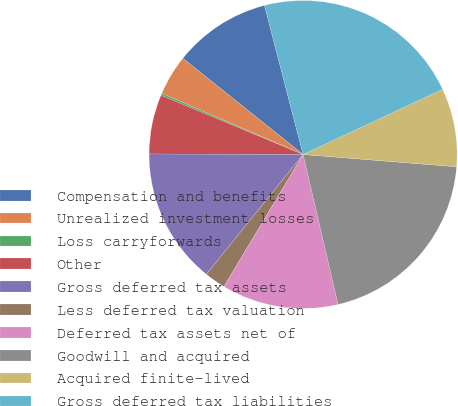Convert chart. <chart><loc_0><loc_0><loc_500><loc_500><pie_chart><fcel>Compensation and benefits<fcel>Unrealized investment losses<fcel>Loss carryforwards<fcel>Other<fcel>Gross deferred tax assets<fcel>Less deferred tax valuation<fcel>Deferred tax assets net of<fcel>Goodwill and acquired<fcel>Acquired finite-lived<fcel>Gross deferred tax liabilities<nl><fcel>10.23%<fcel>4.23%<fcel>0.22%<fcel>6.23%<fcel>14.24%<fcel>2.22%<fcel>12.24%<fcel>20.08%<fcel>8.23%<fcel>22.08%<nl></chart> 